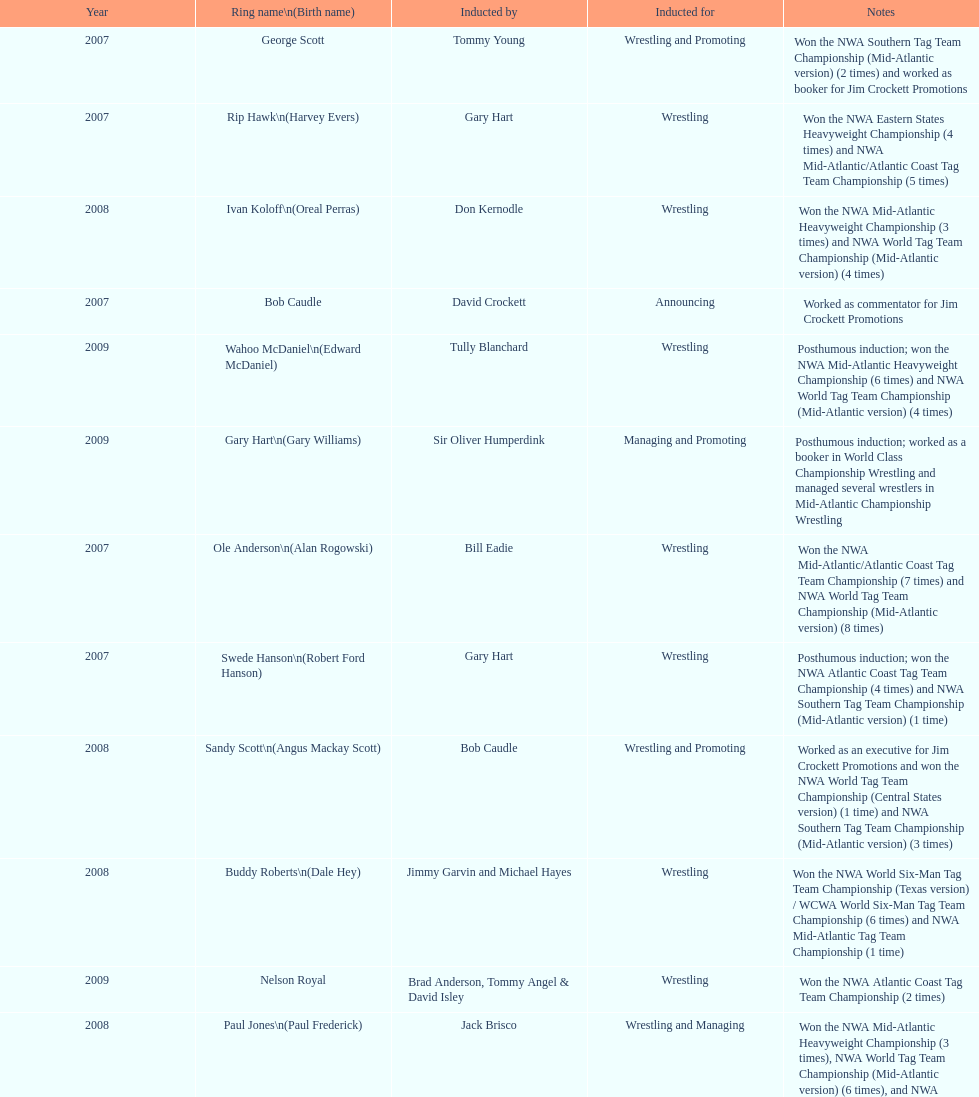Who won the most nwa southern tag team championships (mid-america version)? Jackie Fargo. 